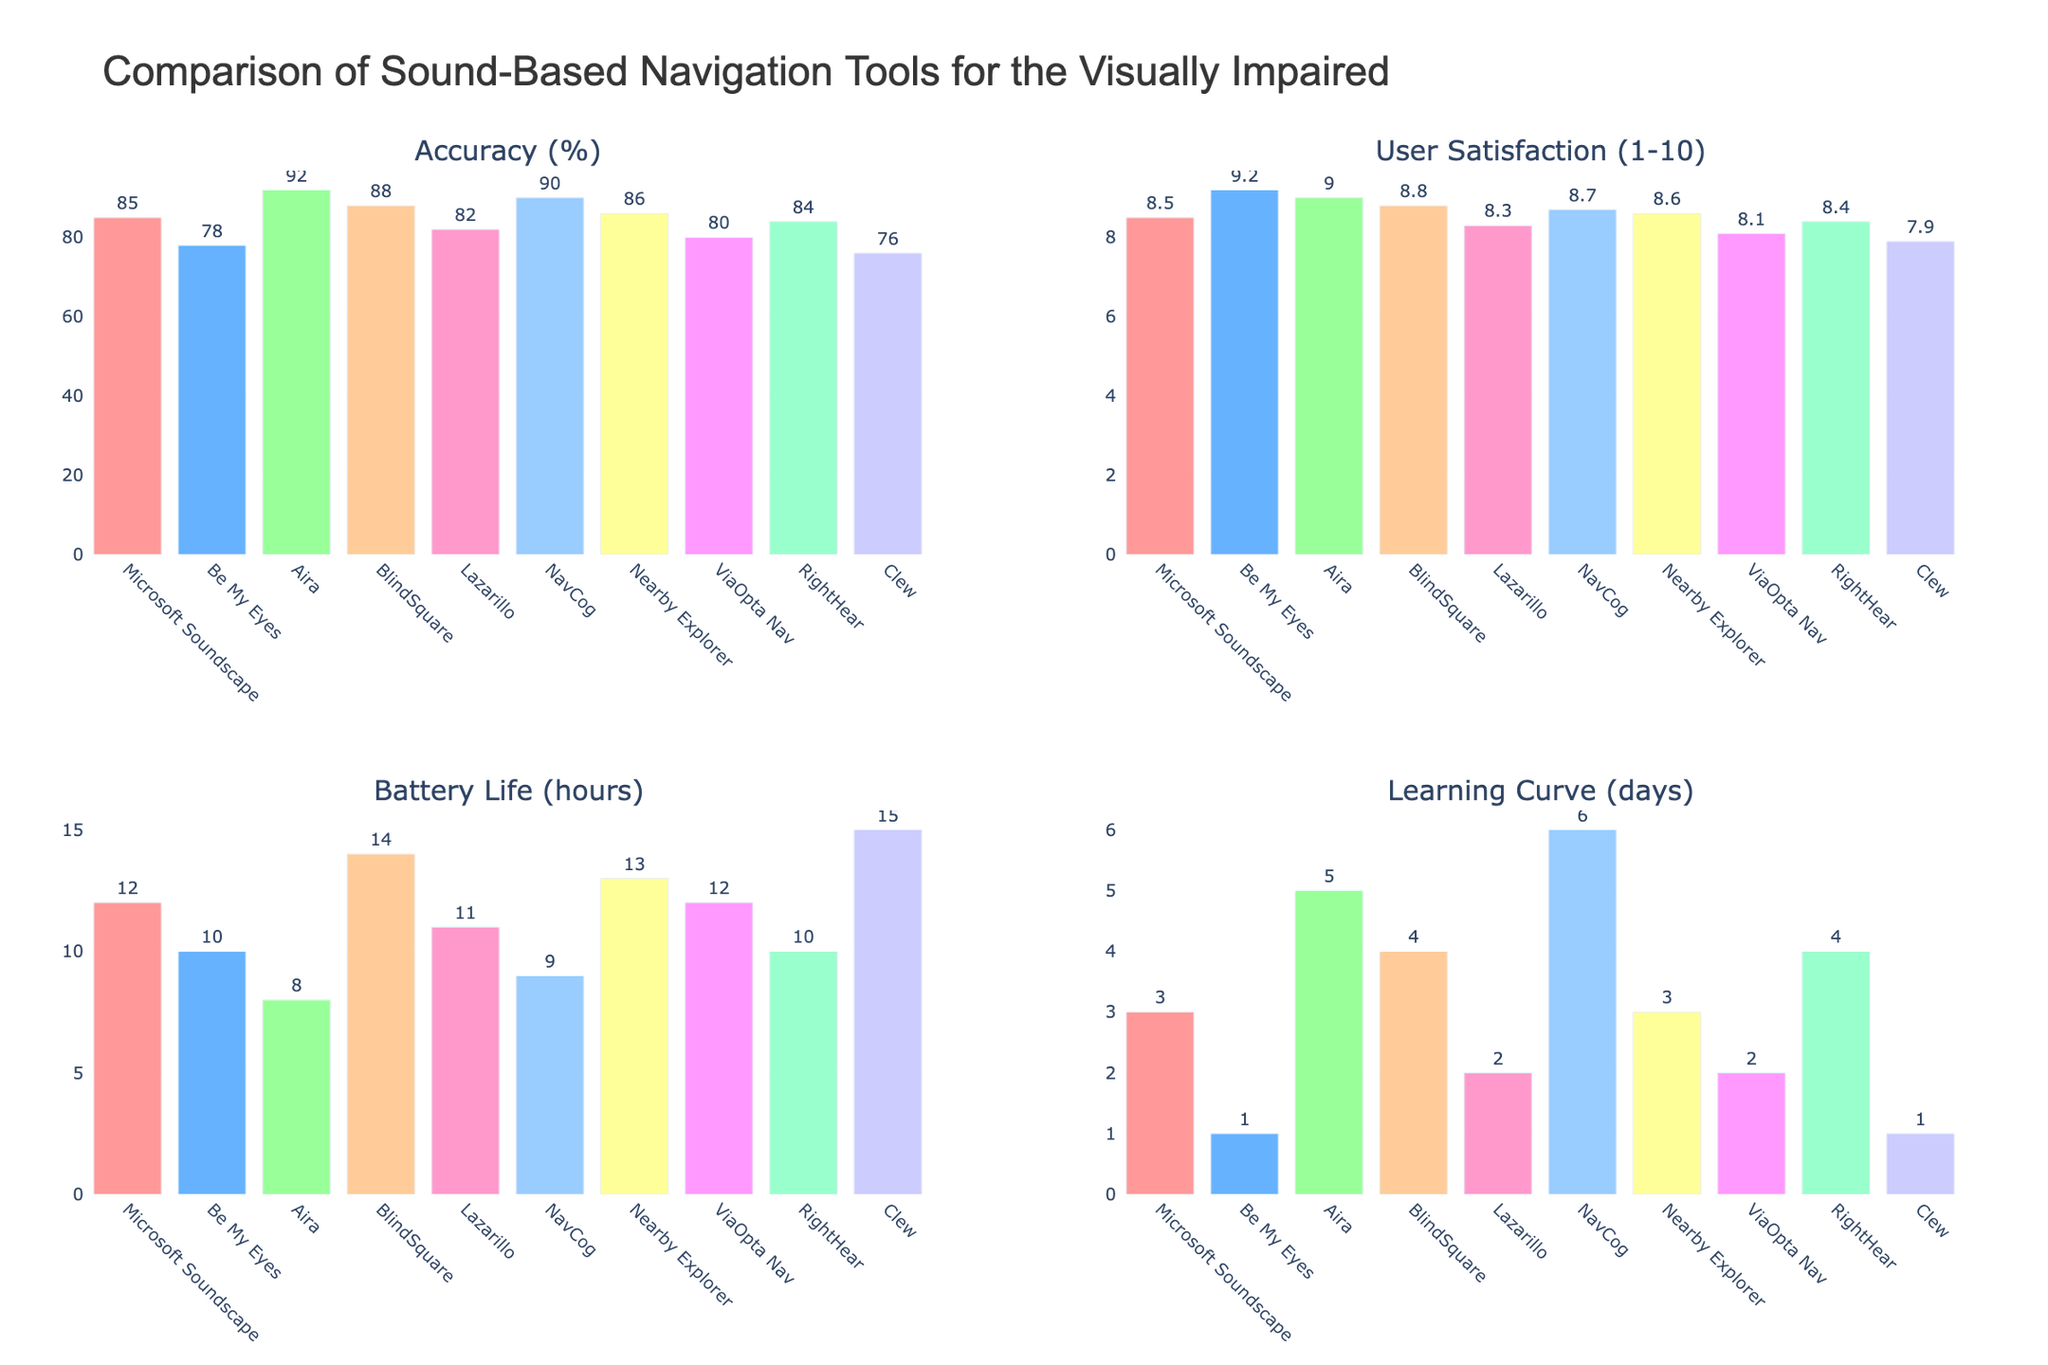How many tools have a user satisfaction rating above 8.5? First, identify tools with user satisfaction ratings greater than 8.5. Be My Eyes, Aira, BlindSquare, and NavCog meet this criterion, totaling four tools with ratings above 8.5.
Answer: 4 Which tool has the highest battery life? Review the bar representing battery life for each tool within the Battery Life subplot. Clew has a battery life value of 15 hours, higher than any other tool.
Answer: Clew Compare Microsoft Soundscape and NavCog: which one has higher user satisfaction and which one has better accuracy? For user satisfaction, Microsoft Soundscape has 8.5 while NavCog has 8.7, so NavCog is higher. For accuracy, Microsoft Soundscape has 85% and NavCog has 90%, so NavCog is also higher in accuracy.
Answer: NavCog (both user satisfaction and accuracy) What is the average battery life of all tools? Add the battery life values of all tools: 12 + 10 + 8 + 14 + 11 + 9 + 13 + 12 + 10 + 15, giving a sum of 114. Then divide by the number of tools, 10, to find the average: 114/10 = 11.4
Answer: 11.4 Which two tools have the shortest learning curve? Examine the bars representing the learning curve data. Both Be My Eyes and Clew have the shortest learning curve of 1 day.
Answer: Be My Eyes, Clew Comparing BlindSquare and Lazarillo, which tool has better overall metrics and why? Assess each metric:
- Accuracy: BlindSquare (88%), Lazarillo (82%) - BlindSquare is better.
- User satisfaction: BlindSquare (8.8), Lazarillo (8.3) - BlindSquare is better.
- Battery life: BlindSquare (14 hours), Lazarillo (11 hours) - BlindSquare is better.
- Learning curve: BlindSquare (4 days), Lazarillo (2 days) - Lazarillo is better, but on balance, BlindSquare fares better in 3/4 metrics.
Answer: BlindSquare, as it excels in accuracy, user satisfaction, and battery life What's the difference in user satisfaction between the highest and lowest rated tools? The highest user satisfaction rating is 9.2 (Be My Eyes), and the lowest is 7.9 (Clew). The difference is 9.2 - 7.9 = 1.3
Answer: 1.3 Which tool has the lowest accuracy, and what is its value? Examine the bars representing accuracy. Clew has the lowest accuracy value at 76%.
Answer: Clew, 76% 